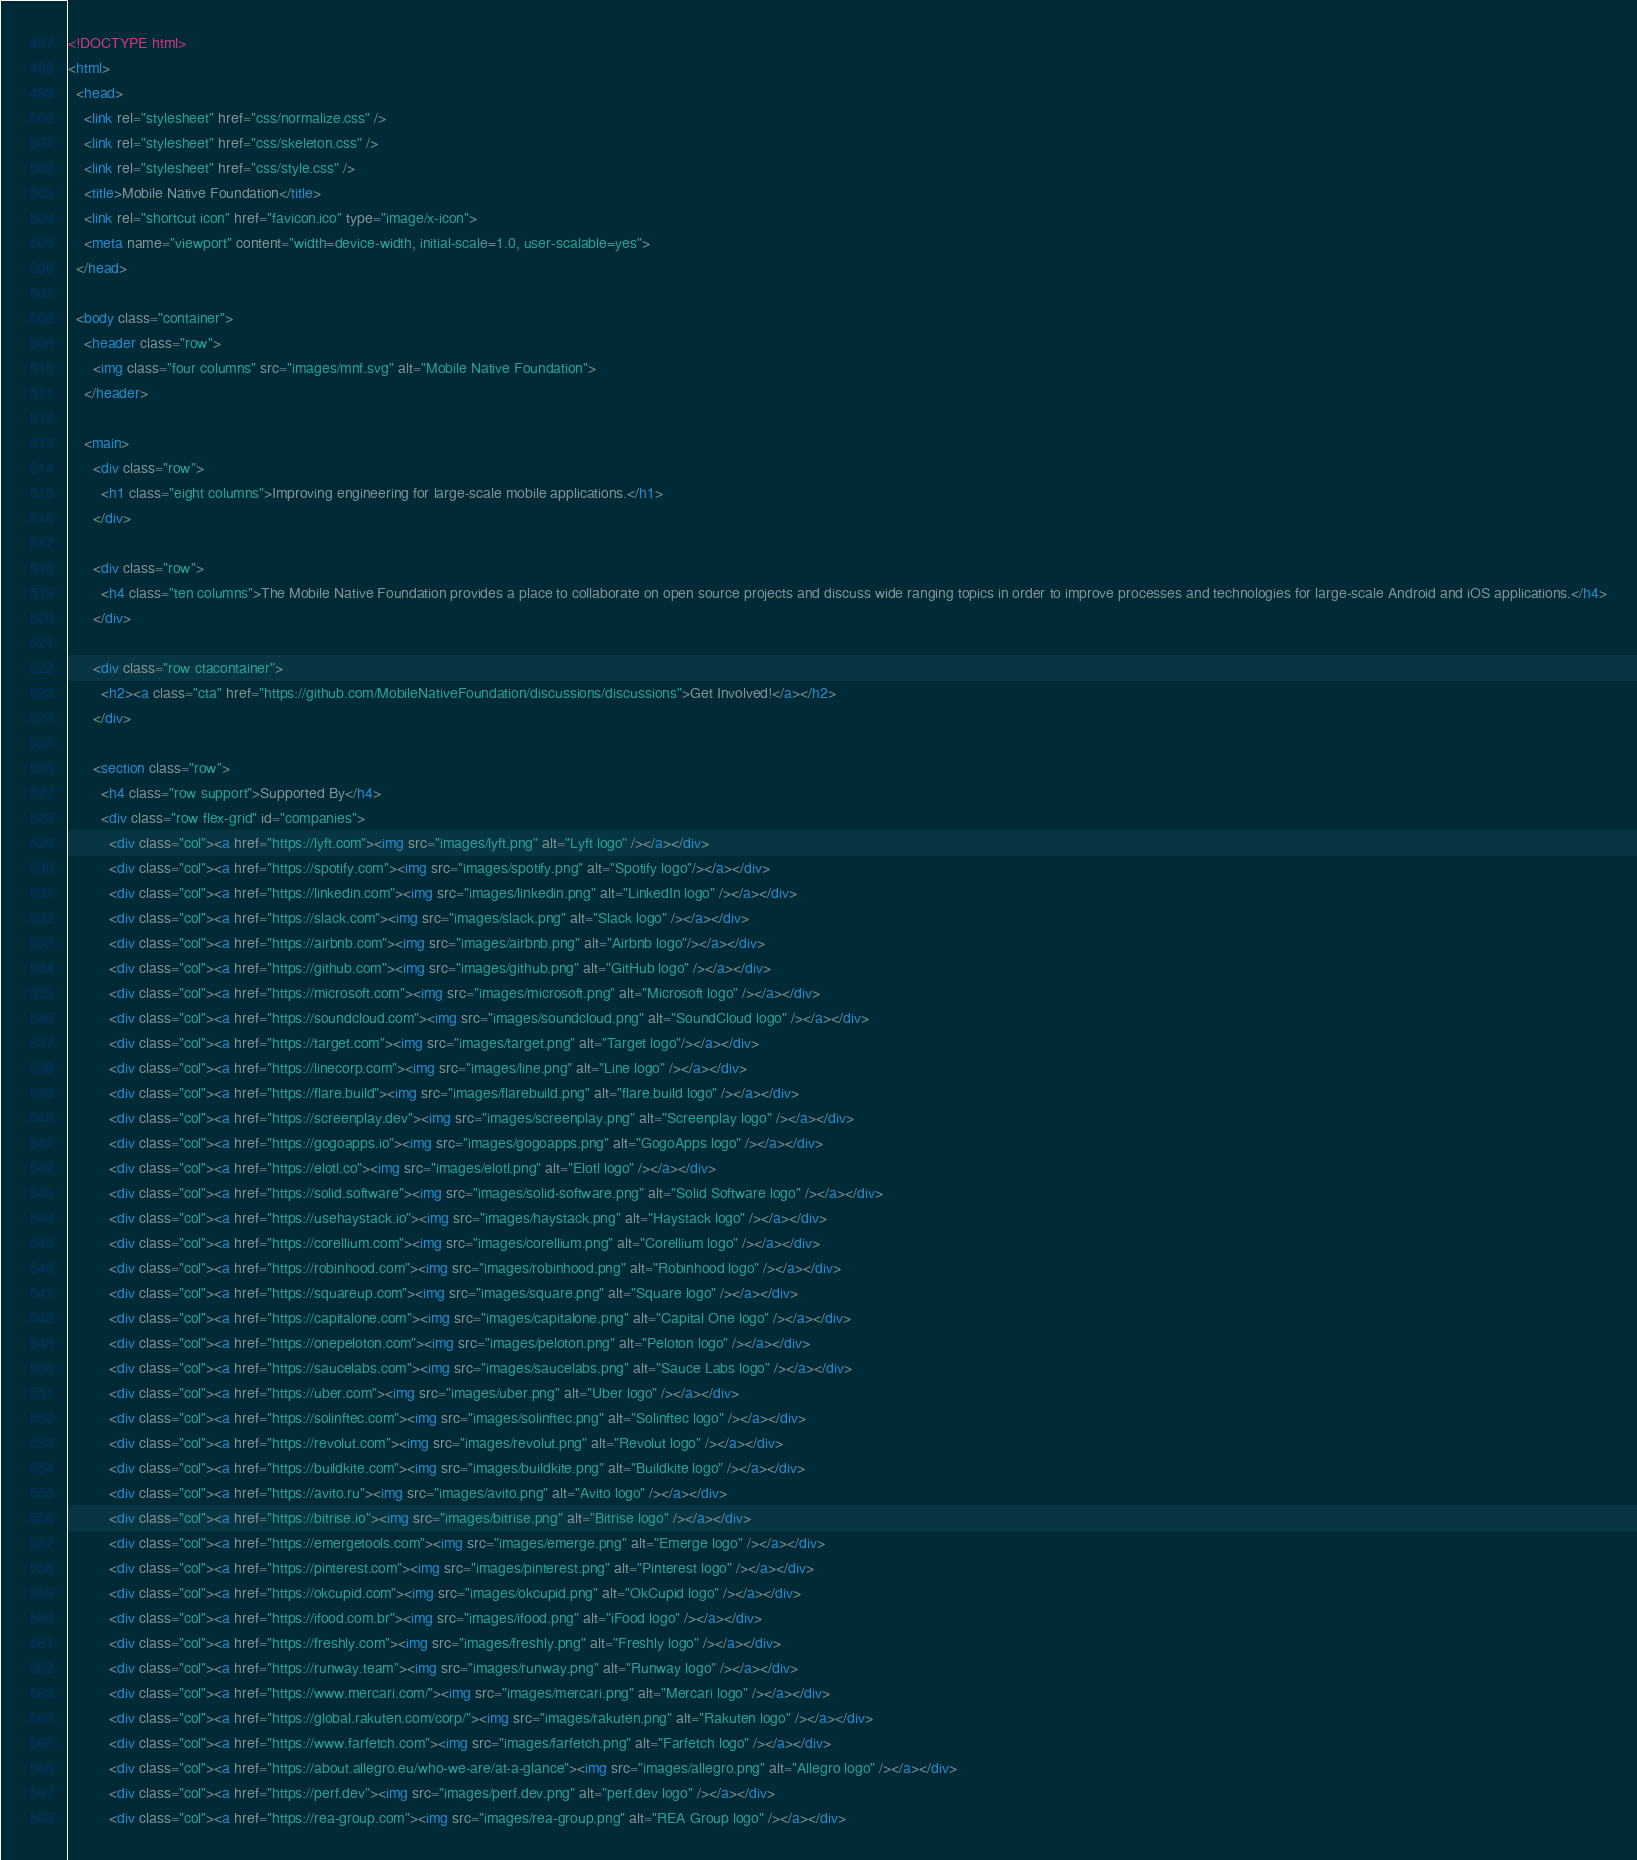<code> <loc_0><loc_0><loc_500><loc_500><_HTML_><!DOCTYPE html>
<html>
  <head>
    <link rel="stylesheet" href="css/normalize.css" />
    <link rel="stylesheet" href="css/skeleton.css" />
    <link rel="stylesheet" href="css/style.css" />
    <title>Mobile Native Foundation</title>
    <link rel="shortcut icon" href="favicon.ico" type="image/x-icon">
    <meta name="viewport" content="width=device-width, initial-scale=1.0, user-scalable=yes">
  </head>

  <body class="container">
    <header class="row">
      <img class="four columns" src="images/mnf.svg" alt="Mobile Native Foundation">
    </header>

    <main>
      <div class="row">
        <h1 class="eight columns">Improving engineering for large-scale mobile applications.</h1>
      </div>

      <div class="row">
        <h4 class="ten columns">The Mobile Native Foundation provides a place to collaborate on open source projects and discuss wide ranging topics in order to improve processes and technologies for large-scale Android and iOS applications.</h4>
      </div>

      <div class="row ctacontainer">
        <h2><a class="cta" href="https://github.com/MobileNativeFoundation/discussions/discussions">Get Involved!</a></h2>
      </div>

      <section class="row">
        <h4 class="row support">Supported By</h4>
        <div class="row flex-grid" id="companies">
          <div class="col"><a href="https://lyft.com"><img src="images/lyft.png" alt="Lyft logo" /></a></div>
          <div class="col"><a href="https://spotify.com"><img src="images/spotify.png" alt="Spotify logo"/></a></div>
          <div class="col"><a href="https://linkedin.com"><img src="images/linkedin.png" alt="LinkedIn logo" /></a></div>
          <div class="col"><a href="https://slack.com"><img src="images/slack.png" alt="Slack logo" /></a></div>
          <div class="col"><a href="https://airbnb.com"><img src="images/airbnb.png" alt="Airbnb logo"/></a></div>
          <div class="col"><a href="https://github.com"><img src="images/github.png" alt="GitHub logo" /></a></div>
          <div class="col"><a href="https://microsoft.com"><img src="images/microsoft.png" alt="Microsoft logo" /></a></div>
          <div class="col"><a href="https://soundcloud.com"><img src="images/soundcloud.png" alt="SoundCloud logo" /></a></div>
          <div class="col"><a href="https://target.com"><img src="images/target.png" alt="Target logo"/></a></div>
          <div class="col"><a href="https://linecorp.com"><img src="images/line.png" alt="Line logo" /></a></div>
          <div class="col"><a href="https://flare.build"><img src="images/flarebuild.png" alt="flare.build logo" /></a></div>
          <div class="col"><a href="https://screenplay.dev"><img src="images/screenplay.png" alt="Screenplay logo" /></a></div>
          <div class="col"><a href="https://gogoapps.io"><img src="images/gogoapps.png" alt="GogoApps logo" /></a></div>
          <div class="col"><a href="https://elotl.co"><img src="images/elotl.png" alt="Elotl logo" /></a></div>
          <div class="col"><a href="https://solid.software"><img src="images/solid-software.png" alt="Solid Software logo" /></a></div>
          <div class="col"><a href="https://usehaystack.io"><img src="images/haystack.png" alt="Haystack logo" /></a></div>
          <div class="col"><a href="https://corellium.com"><img src="images/corellium.png" alt="Corellium logo" /></a></div>
          <div class="col"><a href="https://robinhood.com"><img src="images/robinhood.png" alt="Robinhood logo" /></a></div>
          <div class="col"><a href="https://squareup.com"><img src="images/square.png" alt="Square logo" /></a></div>
          <div class="col"><a href="https://capitalone.com"><img src="images/capitalone.png" alt="Capital One logo" /></a></div>
          <div class="col"><a href="https://onepeloton.com"><img src="images/peloton.png" alt="Peloton logo" /></a></div>
          <div class="col"><a href="https://saucelabs.com"><img src="images/saucelabs.png" alt="Sauce Labs logo" /></a></div>
          <div class="col"><a href="https://uber.com"><img src="images/uber.png" alt="Uber logo" /></a></div>
          <div class="col"><a href="https://solinftec.com"><img src="images/solinftec.png" alt="Solinftec logo" /></a></div>
          <div class="col"><a href="https://revolut.com"><img src="images/revolut.png" alt="Revolut logo" /></a></div>
          <div class="col"><a href="https://buildkite.com"><img src="images/buildkite.png" alt="Buildkite logo" /></a></div>
          <div class="col"><a href="https://avito.ru"><img src="images/avito.png" alt="Avito logo" /></a></div>
          <div class="col"><a href="https://bitrise.io"><img src="images/bitrise.png" alt="Bitrise logo" /></a></div>
          <div class="col"><a href="https://emergetools.com"><img src="images/emerge.png" alt="Emerge logo" /></a></div>
          <div class="col"><a href="https://pinterest.com"><img src="images/pinterest.png" alt="Pinterest logo" /></a></div>
          <div class="col"><a href="https://okcupid.com"><img src="images/okcupid.png" alt="OkCupid logo" /></a></div>
          <div class="col"><a href="https://ifood.com.br"><img src="images/ifood.png" alt="iFood logo" /></a></div>
          <div class="col"><a href="https://freshly.com"><img src="images/freshly.png" alt="Freshly logo" /></a></div>
          <div class="col"><a href="https://runway.team"><img src="images/runway.png" alt="Runway logo" /></a></div>
          <div class="col"><a href="https://www.mercari.com/"><img src="images/mercari.png" alt="Mercari logo" /></a></div>
          <div class="col"><a href="https://global.rakuten.com/corp/"><img src="images/rakuten.png" alt="Rakuten logo" /></a></div>
          <div class="col"><a href="https://www.farfetch.com"><img src="images/farfetch.png" alt="Farfetch logo" /></a></div>
          <div class="col"><a href="https://about.allegro.eu/who-we-are/at-a-glance"><img src="images/allegro.png" alt="Allegro logo" /></a></div>
          <div class="col"><a href="https://perf.dev"><img src="images/perf.dev.png" alt="perf.dev logo" /></a></div>
          <div class="col"><a href="https://rea-group.com"><img src="images/rea-group.png" alt="REA Group logo" /></a></div></code> 